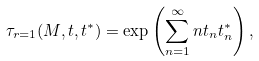<formula> <loc_0><loc_0><loc_500><loc_500>\tau _ { r = 1 } ( M , { t } , { t } ^ { * } ) = \exp \left ( \sum _ { n = 1 } ^ { \infty } n t _ { n } t ^ { * } _ { n } \right ) ,</formula> 